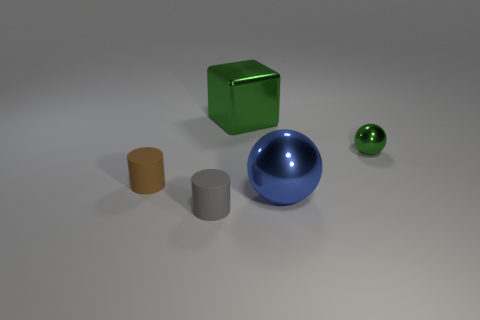Add 3 brown rubber objects. How many objects exist? 8 Subtract 0 yellow balls. How many objects are left? 5 Subtract all balls. How many objects are left? 3 Subtract 2 balls. How many balls are left? 0 Subtract all purple balls. Subtract all brown cubes. How many balls are left? 2 Subtract all large green cubes. Subtract all large blue spheres. How many objects are left? 3 Add 2 brown rubber cylinders. How many brown rubber cylinders are left? 3 Add 4 big metallic balls. How many big metallic balls exist? 5 